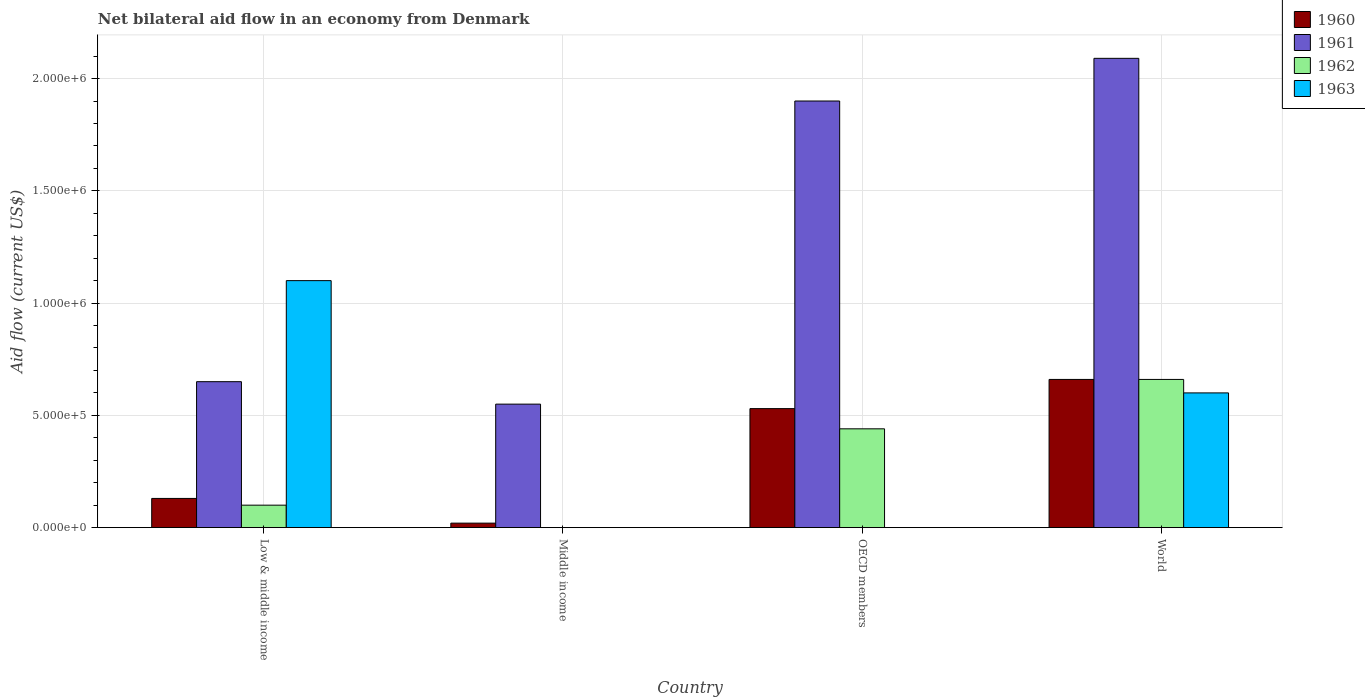Are the number of bars on each tick of the X-axis equal?
Keep it short and to the point. No. How many bars are there on the 3rd tick from the left?
Make the answer very short. 3. How many bars are there on the 2nd tick from the right?
Provide a short and direct response. 3. What is the net bilateral aid flow in 1963 in Middle income?
Offer a very short reply. 0. What is the total net bilateral aid flow in 1963 in the graph?
Your answer should be compact. 1.70e+06. What is the difference between the net bilateral aid flow in 1960 in Low & middle income and that in World?
Keep it short and to the point. -5.30e+05. What is the average net bilateral aid flow in 1962 per country?
Provide a short and direct response. 3.00e+05. What is the difference between the net bilateral aid flow of/in 1961 and net bilateral aid flow of/in 1963 in World?
Offer a terse response. 1.49e+06. In how many countries, is the net bilateral aid flow in 1963 greater than 1200000 US$?
Your answer should be compact. 0. What is the ratio of the net bilateral aid flow in 1960 in Low & middle income to that in OECD members?
Make the answer very short. 0.25. Is the net bilateral aid flow in 1961 in Low & middle income less than that in OECD members?
Ensure brevity in your answer.  Yes. What is the difference between the highest and the second highest net bilateral aid flow in 1961?
Give a very brief answer. 1.44e+06. What is the difference between the highest and the lowest net bilateral aid flow in 1961?
Offer a terse response. 1.54e+06. Is the sum of the net bilateral aid flow in 1960 in Middle income and World greater than the maximum net bilateral aid flow in 1962 across all countries?
Your response must be concise. Yes. How many countries are there in the graph?
Ensure brevity in your answer.  4. What is the difference between two consecutive major ticks on the Y-axis?
Offer a terse response. 5.00e+05. Are the values on the major ticks of Y-axis written in scientific E-notation?
Provide a short and direct response. Yes. Does the graph contain any zero values?
Your answer should be very brief. Yes. Where does the legend appear in the graph?
Your answer should be very brief. Top right. How many legend labels are there?
Keep it short and to the point. 4. How are the legend labels stacked?
Provide a succinct answer. Vertical. What is the title of the graph?
Your answer should be compact. Net bilateral aid flow in an economy from Denmark. Does "1964" appear as one of the legend labels in the graph?
Your answer should be very brief. No. What is the Aid flow (current US$) of 1961 in Low & middle income?
Ensure brevity in your answer.  6.50e+05. What is the Aid flow (current US$) in 1963 in Low & middle income?
Ensure brevity in your answer.  1.10e+06. What is the Aid flow (current US$) of 1960 in Middle income?
Offer a terse response. 2.00e+04. What is the Aid flow (current US$) in 1961 in Middle income?
Keep it short and to the point. 5.50e+05. What is the Aid flow (current US$) in 1962 in Middle income?
Provide a short and direct response. 0. What is the Aid flow (current US$) in 1963 in Middle income?
Your answer should be very brief. 0. What is the Aid flow (current US$) of 1960 in OECD members?
Your answer should be very brief. 5.30e+05. What is the Aid flow (current US$) of 1961 in OECD members?
Offer a terse response. 1.90e+06. What is the Aid flow (current US$) of 1962 in OECD members?
Your answer should be compact. 4.40e+05. What is the Aid flow (current US$) in 1961 in World?
Give a very brief answer. 2.09e+06. What is the Aid flow (current US$) of 1962 in World?
Provide a short and direct response. 6.60e+05. What is the Aid flow (current US$) in 1963 in World?
Keep it short and to the point. 6.00e+05. Across all countries, what is the maximum Aid flow (current US$) in 1960?
Ensure brevity in your answer.  6.60e+05. Across all countries, what is the maximum Aid flow (current US$) of 1961?
Offer a terse response. 2.09e+06. Across all countries, what is the maximum Aid flow (current US$) of 1962?
Provide a short and direct response. 6.60e+05. Across all countries, what is the maximum Aid flow (current US$) of 1963?
Your answer should be compact. 1.10e+06. Across all countries, what is the minimum Aid flow (current US$) in 1960?
Your response must be concise. 2.00e+04. Across all countries, what is the minimum Aid flow (current US$) of 1962?
Your response must be concise. 0. Across all countries, what is the minimum Aid flow (current US$) in 1963?
Your answer should be very brief. 0. What is the total Aid flow (current US$) in 1960 in the graph?
Provide a short and direct response. 1.34e+06. What is the total Aid flow (current US$) in 1961 in the graph?
Offer a very short reply. 5.19e+06. What is the total Aid flow (current US$) of 1962 in the graph?
Offer a terse response. 1.20e+06. What is the total Aid flow (current US$) of 1963 in the graph?
Provide a short and direct response. 1.70e+06. What is the difference between the Aid flow (current US$) in 1961 in Low & middle income and that in Middle income?
Your answer should be compact. 1.00e+05. What is the difference between the Aid flow (current US$) in 1960 in Low & middle income and that in OECD members?
Offer a very short reply. -4.00e+05. What is the difference between the Aid flow (current US$) in 1961 in Low & middle income and that in OECD members?
Make the answer very short. -1.25e+06. What is the difference between the Aid flow (current US$) in 1962 in Low & middle income and that in OECD members?
Make the answer very short. -3.40e+05. What is the difference between the Aid flow (current US$) in 1960 in Low & middle income and that in World?
Offer a terse response. -5.30e+05. What is the difference between the Aid flow (current US$) in 1961 in Low & middle income and that in World?
Give a very brief answer. -1.44e+06. What is the difference between the Aid flow (current US$) in 1962 in Low & middle income and that in World?
Your response must be concise. -5.60e+05. What is the difference between the Aid flow (current US$) in 1963 in Low & middle income and that in World?
Keep it short and to the point. 5.00e+05. What is the difference between the Aid flow (current US$) of 1960 in Middle income and that in OECD members?
Your answer should be very brief. -5.10e+05. What is the difference between the Aid flow (current US$) of 1961 in Middle income and that in OECD members?
Give a very brief answer. -1.35e+06. What is the difference between the Aid flow (current US$) of 1960 in Middle income and that in World?
Your response must be concise. -6.40e+05. What is the difference between the Aid flow (current US$) of 1961 in Middle income and that in World?
Ensure brevity in your answer.  -1.54e+06. What is the difference between the Aid flow (current US$) in 1962 in OECD members and that in World?
Provide a succinct answer. -2.20e+05. What is the difference between the Aid flow (current US$) in 1960 in Low & middle income and the Aid flow (current US$) in 1961 in Middle income?
Keep it short and to the point. -4.20e+05. What is the difference between the Aid flow (current US$) in 1960 in Low & middle income and the Aid flow (current US$) in 1961 in OECD members?
Make the answer very short. -1.77e+06. What is the difference between the Aid flow (current US$) of 1960 in Low & middle income and the Aid flow (current US$) of 1962 in OECD members?
Make the answer very short. -3.10e+05. What is the difference between the Aid flow (current US$) in 1961 in Low & middle income and the Aid flow (current US$) in 1962 in OECD members?
Provide a short and direct response. 2.10e+05. What is the difference between the Aid flow (current US$) of 1960 in Low & middle income and the Aid flow (current US$) of 1961 in World?
Offer a terse response. -1.96e+06. What is the difference between the Aid flow (current US$) of 1960 in Low & middle income and the Aid flow (current US$) of 1962 in World?
Your answer should be very brief. -5.30e+05. What is the difference between the Aid flow (current US$) in 1960 in Low & middle income and the Aid flow (current US$) in 1963 in World?
Offer a terse response. -4.70e+05. What is the difference between the Aid flow (current US$) of 1962 in Low & middle income and the Aid flow (current US$) of 1963 in World?
Give a very brief answer. -5.00e+05. What is the difference between the Aid flow (current US$) in 1960 in Middle income and the Aid flow (current US$) in 1961 in OECD members?
Offer a terse response. -1.88e+06. What is the difference between the Aid flow (current US$) in 1960 in Middle income and the Aid flow (current US$) in 1962 in OECD members?
Your answer should be very brief. -4.20e+05. What is the difference between the Aid flow (current US$) of 1960 in Middle income and the Aid flow (current US$) of 1961 in World?
Your answer should be very brief. -2.07e+06. What is the difference between the Aid flow (current US$) of 1960 in Middle income and the Aid flow (current US$) of 1962 in World?
Offer a terse response. -6.40e+05. What is the difference between the Aid flow (current US$) in 1960 in Middle income and the Aid flow (current US$) in 1963 in World?
Make the answer very short. -5.80e+05. What is the difference between the Aid flow (current US$) of 1961 in Middle income and the Aid flow (current US$) of 1962 in World?
Your answer should be very brief. -1.10e+05. What is the difference between the Aid flow (current US$) of 1961 in Middle income and the Aid flow (current US$) of 1963 in World?
Your answer should be very brief. -5.00e+04. What is the difference between the Aid flow (current US$) of 1960 in OECD members and the Aid flow (current US$) of 1961 in World?
Your answer should be compact. -1.56e+06. What is the difference between the Aid flow (current US$) of 1960 in OECD members and the Aid flow (current US$) of 1963 in World?
Offer a terse response. -7.00e+04. What is the difference between the Aid flow (current US$) in 1961 in OECD members and the Aid flow (current US$) in 1962 in World?
Your answer should be very brief. 1.24e+06. What is the difference between the Aid flow (current US$) of 1961 in OECD members and the Aid flow (current US$) of 1963 in World?
Ensure brevity in your answer.  1.30e+06. What is the difference between the Aid flow (current US$) of 1962 in OECD members and the Aid flow (current US$) of 1963 in World?
Your answer should be compact. -1.60e+05. What is the average Aid flow (current US$) of 1960 per country?
Your answer should be very brief. 3.35e+05. What is the average Aid flow (current US$) in 1961 per country?
Provide a short and direct response. 1.30e+06. What is the average Aid flow (current US$) in 1963 per country?
Make the answer very short. 4.25e+05. What is the difference between the Aid flow (current US$) in 1960 and Aid flow (current US$) in 1961 in Low & middle income?
Your response must be concise. -5.20e+05. What is the difference between the Aid flow (current US$) in 1960 and Aid flow (current US$) in 1963 in Low & middle income?
Ensure brevity in your answer.  -9.70e+05. What is the difference between the Aid flow (current US$) of 1961 and Aid flow (current US$) of 1962 in Low & middle income?
Your response must be concise. 5.50e+05. What is the difference between the Aid flow (current US$) of 1961 and Aid flow (current US$) of 1963 in Low & middle income?
Ensure brevity in your answer.  -4.50e+05. What is the difference between the Aid flow (current US$) of 1960 and Aid flow (current US$) of 1961 in Middle income?
Provide a short and direct response. -5.30e+05. What is the difference between the Aid flow (current US$) in 1960 and Aid flow (current US$) in 1961 in OECD members?
Offer a very short reply. -1.37e+06. What is the difference between the Aid flow (current US$) of 1960 and Aid flow (current US$) of 1962 in OECD members?
Your answer should be very brief. 9.00e+04. What is the difference between the Aid flow (current US$) of 1961 and Aid flow (current US$) of 1962 in OECD members?
Keep it short and to the point. 1.46e+06. What is the difference between the Aid flow (current US$) in 1960 and Aid flow (current US$) in 1961 in World?
Your answer should be very brief. -1.43e+06. What is the difference between the Aid flow (current US$) in 1960 and Aid flow (current US$) in 1963 in World?
Keep it short and to the point. 6.00e+04. What is the difference between the Aid flow (current US$) of 1961 and Aid flow (current US$) of 1962 in World?
Your answer should be compact. 1.43e+06. What is the difference between the Aid flow (current US$) in 1961 and Aid flow (current US$) in 1963 in World?
Your response must be concise. 1.49e+06. What is the ratio of the Aid flow (current US$) in 1960 in Low & middle income to that in Middle income?
Provide a short and direct response. 6.5. What is the ratio of the Aid flow (current US$) of 1961 in Low & middle income to that in Middle income?
Your response must be concise. 1.18. What is the ratio of the Aid flow (current US$) in 1960 in Low & middle income to that in OECD members?
Offer a terse response. 0.25. What is the ratio of the Aid flow (current US$) of 1961 in Low & middle income to that in OECD members?
Keep it short and to the point. 0.34. What is the ratio of the Aid flow (current US$) of 1962 in Low & middle income to that in OECD members?
Offer a very short reply. 0.23. What is the ratio of the Aid flow (current US$) in 1960 in Low & middle income to that in World?
Your answer should be very brief. 0.2. What is the ratio of the Aid flow (current US$) in 1961 in Low & middle income to that in World?
Your answer should be very brief. 0.31. What is the ratio of the Aid flow (current US$) of 1962 in Low & middle income to that in World?
Keep it short and to the point. 0.15. What is the ratio of the Aid flow (current US$) in 1963 in Low & middle income to that in World?
Provide a succinct answer. 1.83. What is the ratio of the Aid flow (current US$) in 1960 in Middle income to that in OECD members?
Provide a succinct answer. 0.04. What is the ratio of the Aid flow (current US$) in 1961 in Middle income to that in OECD members?
Offer a very short reply. 0.29. What is the ratio of the Aid flow (current US$) of 1960 in Middle income to that in World?
Ensure brevity in your answer.  0.03. What is the ratio of the Aid flow (current US$) of 1961 in Middle income to that in World?
Provide a short and direct response. 0.26. What is the ratio of the Aid flow (current US$) of 1960 in OECD members to that in World?
Give a very brief answer. 0.8. What is the ratio of the Aid flow (current US$) in 1961 in OECD members to that in World?
Offer a very short reply. 0.91. What is the ratio of the Aid flow (current US$) in 1962 in OECD members to that in World?
Ensure brevity in your answer.  0.67. What is the difference between the highest and the second highest Aid flow (current US$) in 1961?
Offer a terse response. 1.90e+05. What is the difference between the highest and the second highest Aid flow (current US$) in 1962?
Give a very brief answer. 2.20e+05. What is the difference between the highest and the lowest Aid flow (current US$) of 1960?
Your answer should be very brief. 6.40e+05. What is the difference between the highest and the lowest Aid flow (current US$) in 1961?
Offer a very short reply. 1.54e+06. What is the difference between the highest and the lowest Aid flow (current US$) of 1963?
Your answer should be very brief. 1.10e+06. 